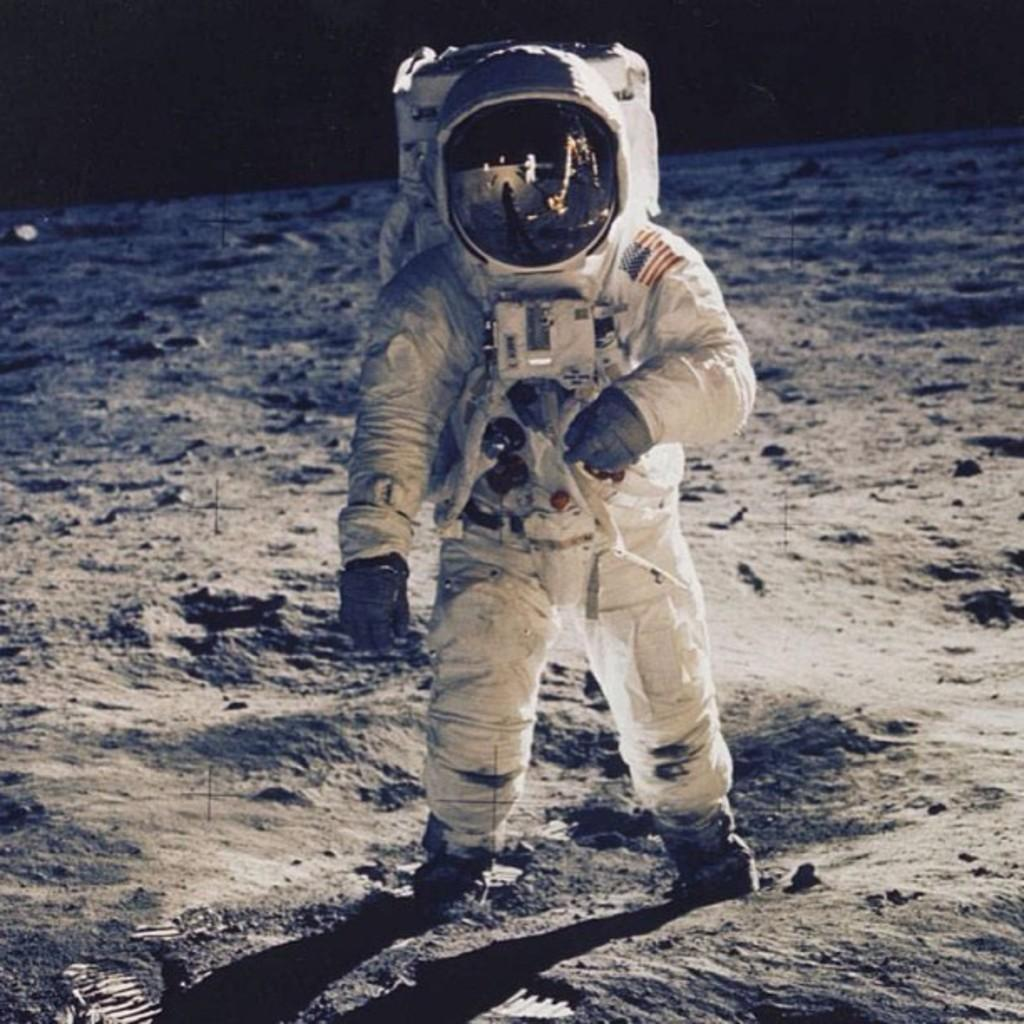What is the main subject of the image? There is an astronaut in the image. What is the astronaut wearing? The astronaut is wearing a white dress. What type of feather can be seen floating near the astronaut in the image? There is no feather present in the image; it features an astronaut wearing a white dress. How many bags is the astronaut carrying in the image? There are no bags visible in the image; it only shows an astronaut wearing a white dress. 